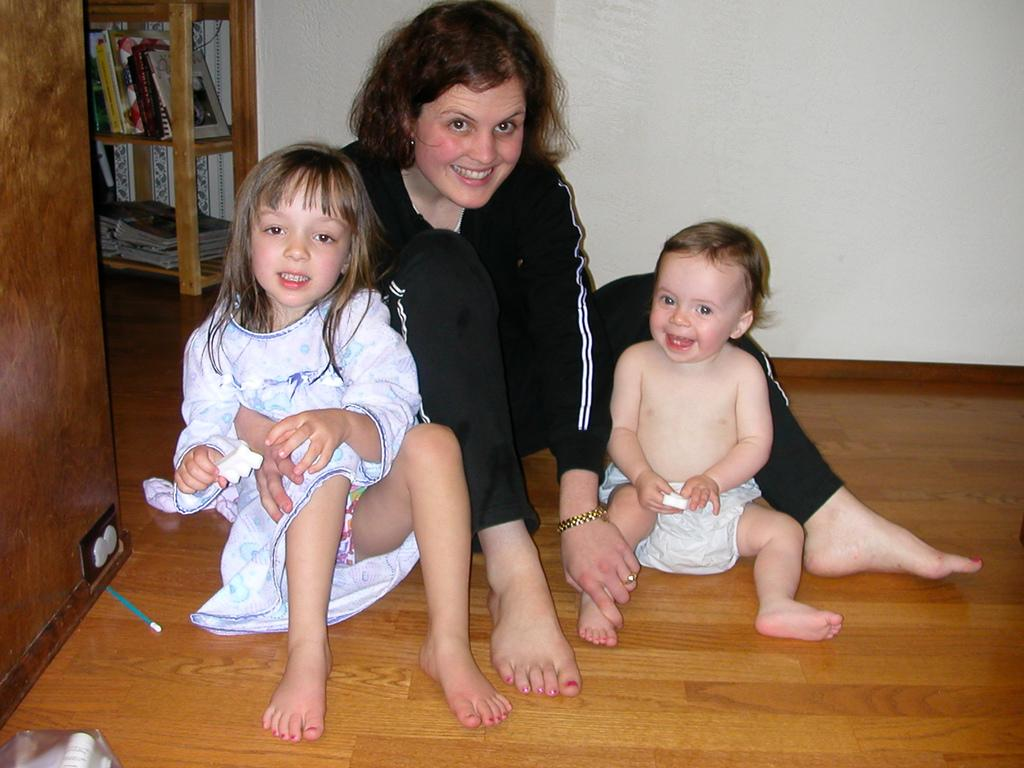Who or what can be seen in the image? There are people in the image. Can you describe the position of the baby in the image? A baby is sitting on the brown color floor. Where are the books located in the image? The books are in a wooden rack. What is visible in the background of the image? There is a wall visible in the image. What else can be observed in the image besides the people and the baby? There are objects present in the image. What type of riddle is written on the wall in the image? There is no riddle written on the wall in the image; only a wall is visible in the background. 